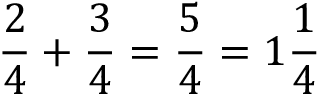<formula> <loc_0><loc_0><loc_500><loc_500>{ \frac { 2 } { 4 } } + { \frac { 3 } { 4 } } = { \frac { 5 } { 4 } } = 1 { \frac { 1 } { 4 } }</formula> 